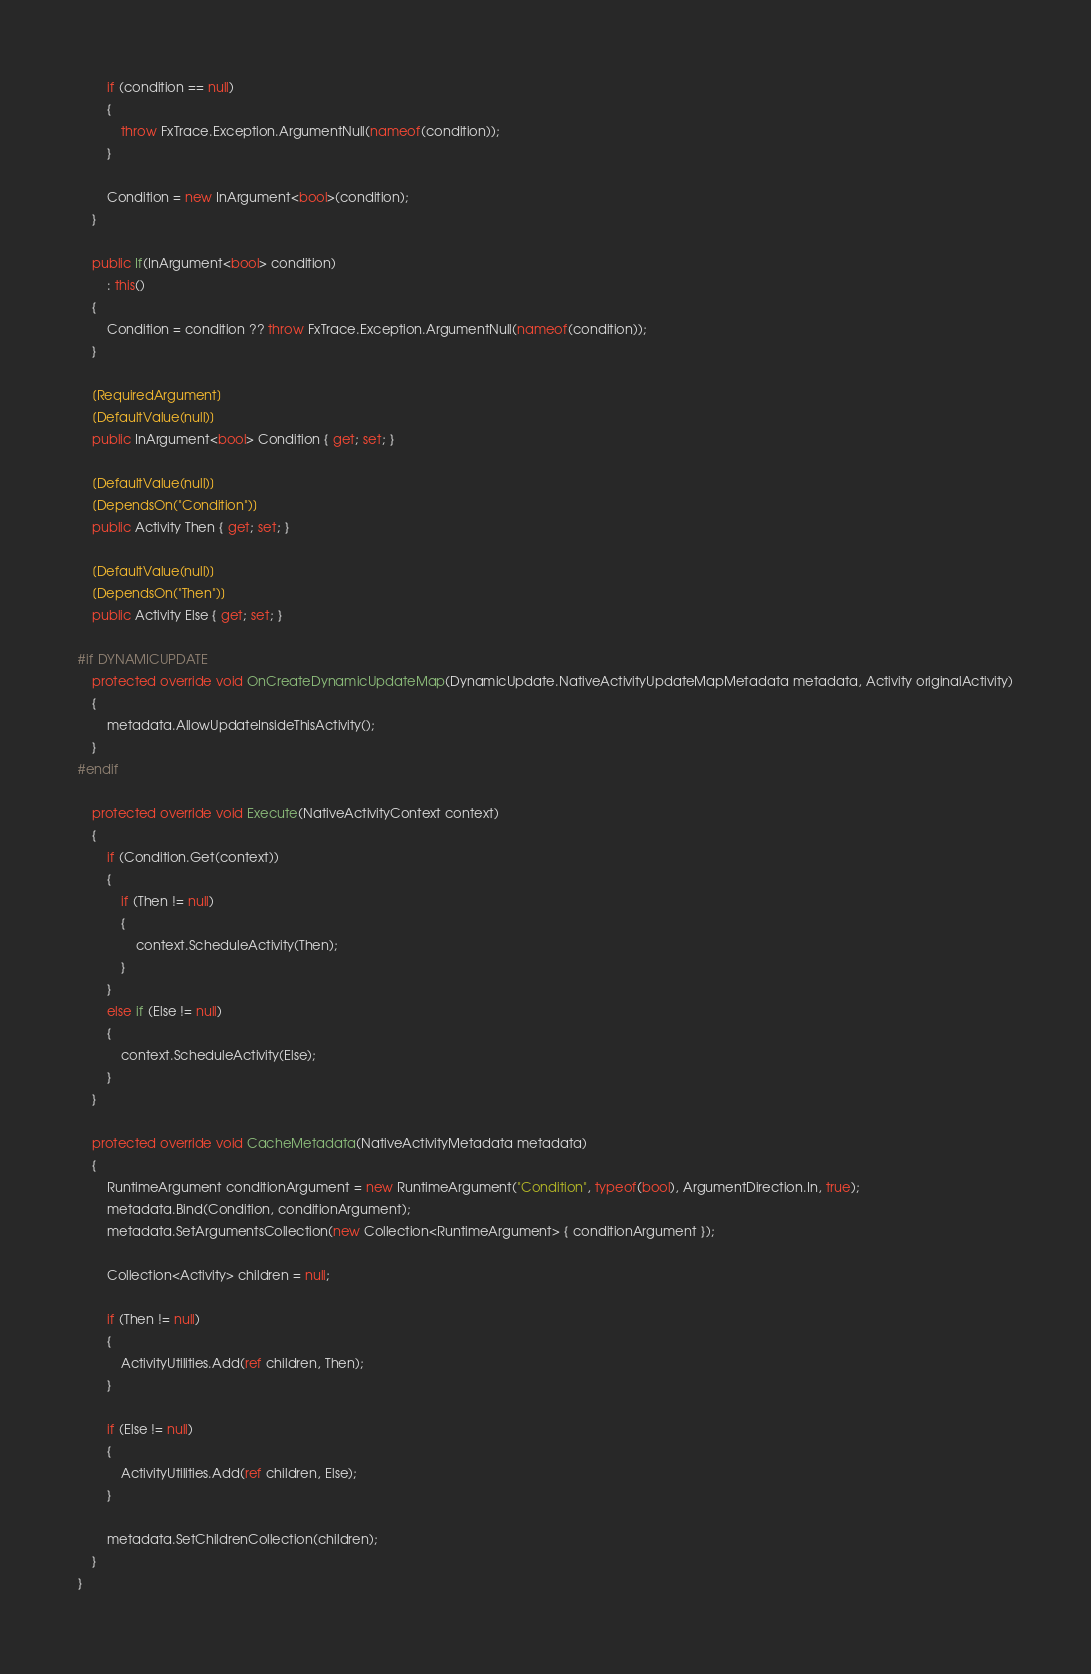<code> <loc_0><loc_0><loc_500><loc_500><_C#_>        if (condition == null)
        {
            throw FxTrace.Exception.ArgumentNull(nameof(condition));
        }

        Condition = new InArgument<bool>(condition);
    }

    public If(InArgument<bool> condition)
        : this()
    {
        Condition = condition ?? throw FxTrace.Exception.ArgumentNull(nameof(condition));
    }

    [RequiredArgument]
    [DefaultValue(null)]
    public InArgument<bool> Condition { get; set; }

    [DefaultValue(null)]
    [DependsOn("Condition")]
    public Activity Then { get; set; }

    [DefaultValue(null)]
    [DependsOn("Then")]
    public Activity Else { get; set; }

#if DYNAMICUPDATE
    protected override void OnCreateDynamicUpdateMap(DynamicUpdate.NativeActivityUpdateMapMetadata metadata, Activity originalActivity)
    {
        metadata.AllowUpdateInsideThisActivity();
    } 
#endif

    protected override void Execute(NativeActivityContext context)
    {
        if (Condition.Get(context))
        {
            if (Then != null)
            {
                context.ScheduleActivity(Then);
            }
        }
        else if (Else != null)
        {
            context.ScheduleActivity(Else);
        }
    }

    protected override void CacheMetadata(NativeActivityMetadata metadata)
    {
        RuntimeArgument conditionArgument = new RuntimeArgument("Condition", typeof(bool), ArgumentDirection.In, true);
        metadata.Bind(Condition, conditionArgument);
        metadata.SetArgumentsCollection(new Collection<RuntimeArgument> { conditionArgument });

        Collection<Activity> children = null;

        if (Then != null)
        {
            ActivityUtilities.Add(ref children, Then);
        }

        if (Else != null)
        {
            ActivityUtilities.Add(ref children, Else);
        }

        metadata.SetChildrenCollection(children);
    }
}
</code> 